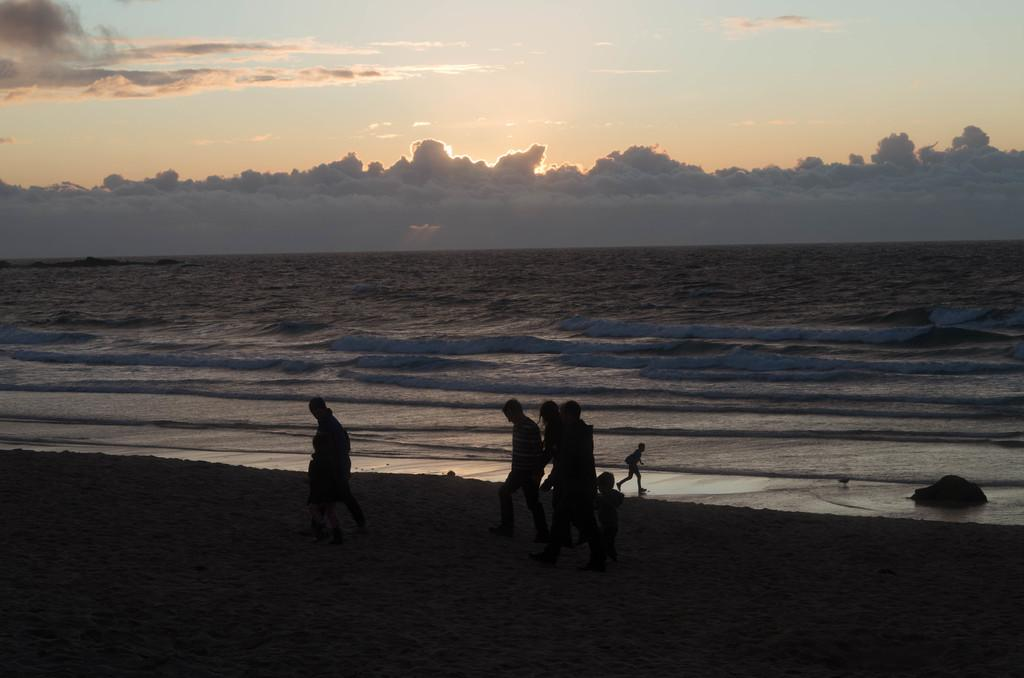How many people are in the image? There is a group of persons in the image. What are the persons in the image doing? The group of persons is walking on the seaside. What can be seen in the background of the image? There are water waves and a sky visible in the image. What is the condition of the sky in the image? The sky contains clouds. What is the tax rate for the family in the image? There is no mention of a family or tax in the image, so it is not possible to determine the tax rate. 